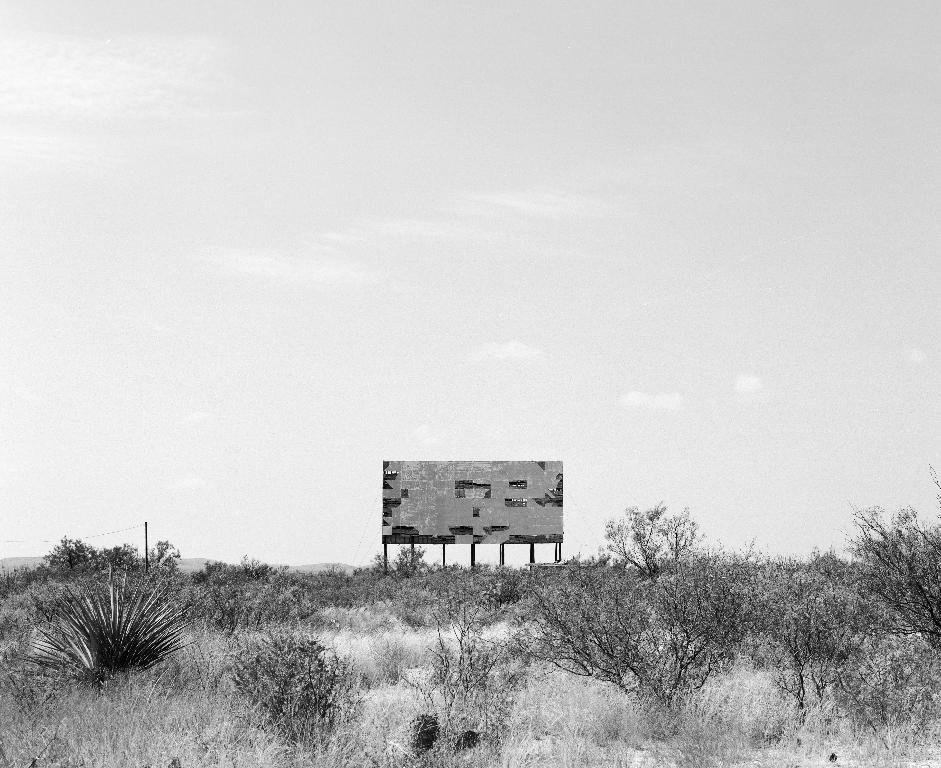What type of vegetation is present at the bottom of the image? There are plants and grass at the bottom of the image. What structure is located in the center of the image? There is a hoarding in the center of the image. What is visible at the top of the image? The sky is visible at the top of the image. How many sheep are visible in the image? There are no sheep present in the image. What type of oven is used to cook the plants in the image? There are no ovens or cooking involved in the image; it features plants and grass. 